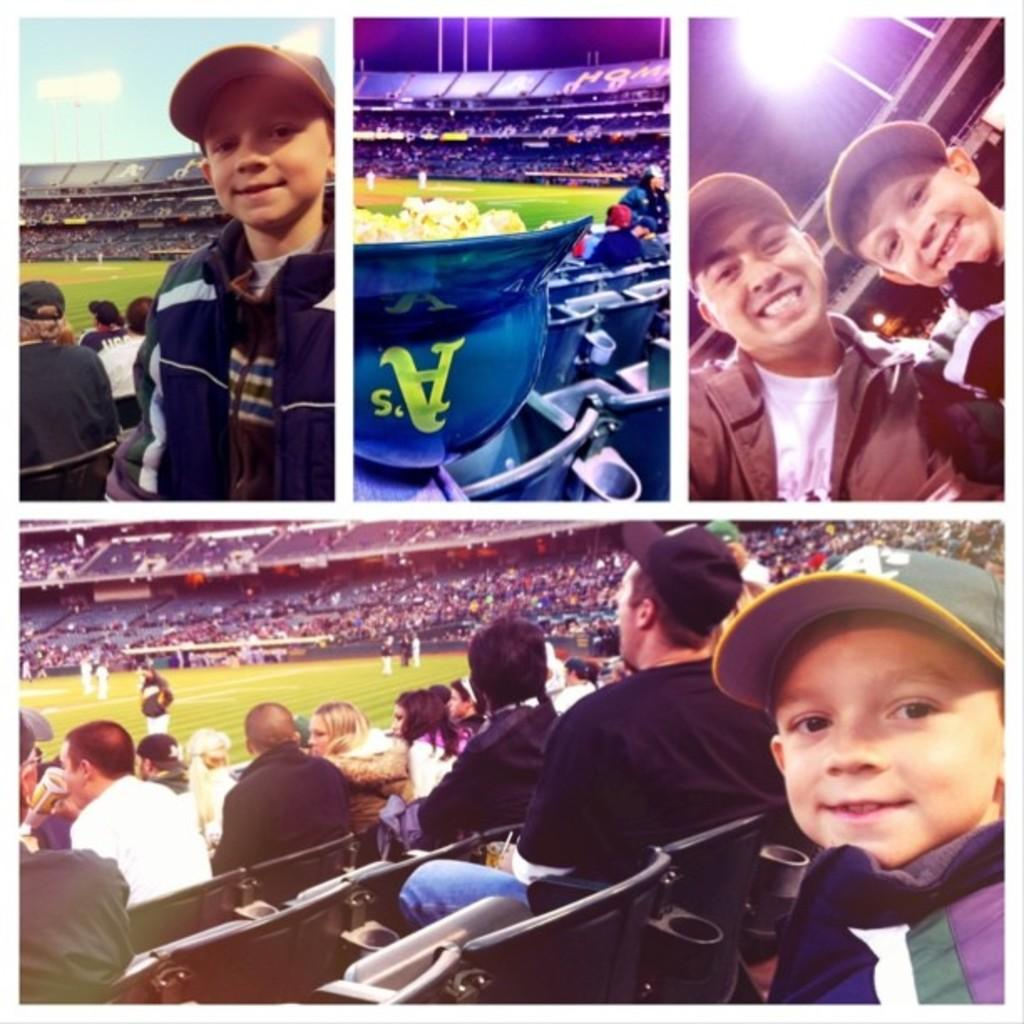What type of artwork is the image? The image is a collage. What structure can be seen in the image? There is a stadium in the image. Are there any people present in the image? Yes, there are people in the image. What type of furniture is visible in the image? There are chairs in the image. What architectural feature is present in the image? There is a skylight in the image. What type of support structures are in the image? There are poles in the image. Can you describe the individuals in the image? There is a boy and a man wearing a cap in the image. What type of boats can be seen sailing in the image? There are no boats present in the image; it is a collage featuring a stadium, people, chairs, a skylight, and poles. 